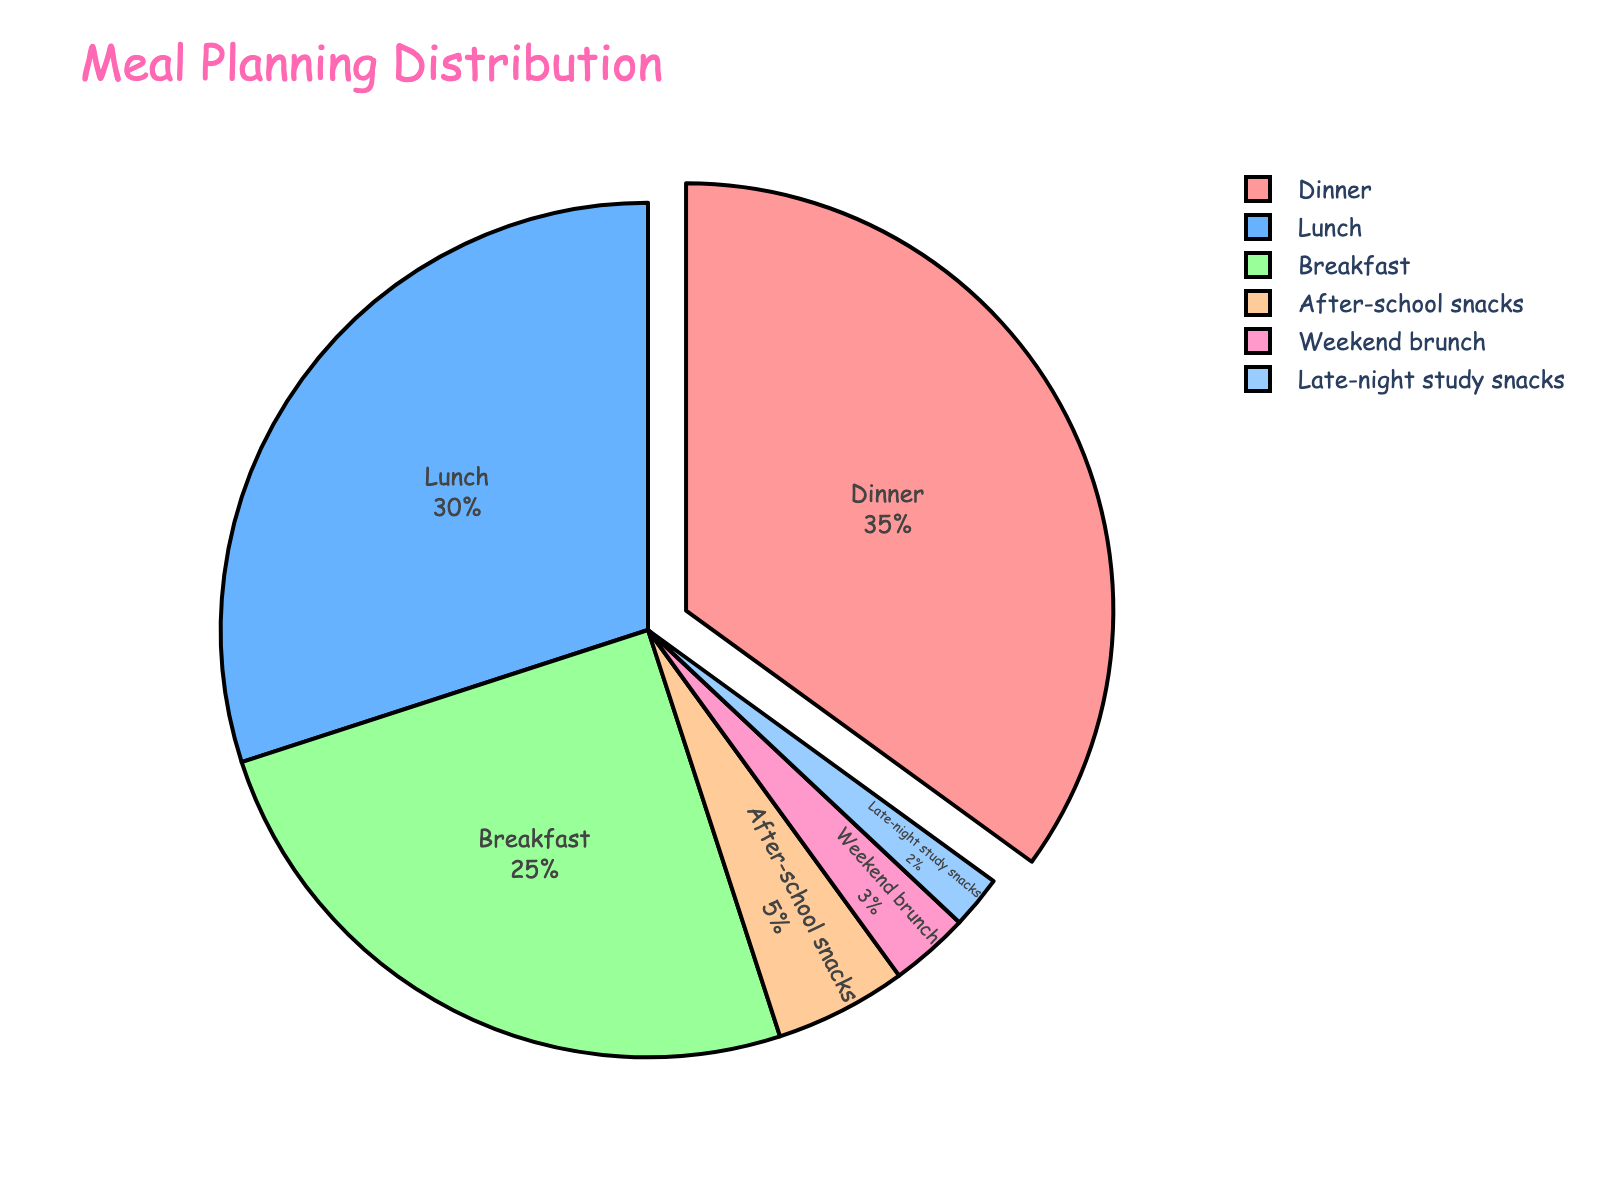What meal time has the lowest percentage? The pie chart divides the meals based on their planned percentages. By observing the chart, Late-night study snacks have the smallest segment.
Answer: Late-night study snacks How much percentage is allocated to Lunch compared to Breakfast? The chart shows Lunch is 30% and Breakfast is 25%. The difference is 30% - 25%.
Answer: 5% What's the total percentage for snacks (both after-school and late-night study)? Add the percentages of After-school snacks (5%) and Late-night study snacks (2%). The total is 5% + 2%.
Answer: 7% Which meal time has the highest percentage? The segments of the chart illustrate that Dinner has the largest portion at 35%.
Answer: Dinner Is the percentage for Weekend brunch higher or lower than After-school snacks? The chart shows Weekend brunch is 3% and After-school snacks is 5%. Comparing the two, 3% < 5%.
Answer: Lower What's the combined percentage for Breakfast and Dinner? Add the percentages of Breakfast and Dinner. Breakfast is 25% and Dinner is 35%. The total is 25% + 35%.
Answer: 60% Which has a larger percentage: Breakfast or Lunch? By examining the portions, Lunch is 30% while Breakfast is 25%. So, Lunch has the larger percentage.
Answer: Lunch What is the difference in percentage between Dinner and Weekend brunch? Subtract the percentage of Weekend brunch from Dinner: 35% - 3%.
Answer: 32% What's the percentage difference between Lunch and Dinner? Subtract Lunch's percentage from Dinner's: 35% - 30%.
Answer: 5% Compare the visual color: What color represents Breakfast in the pie chart? By looking at the pie chart and the corresponding segments, the color for Breakfast is identified as the light red.
Answer: Light red 